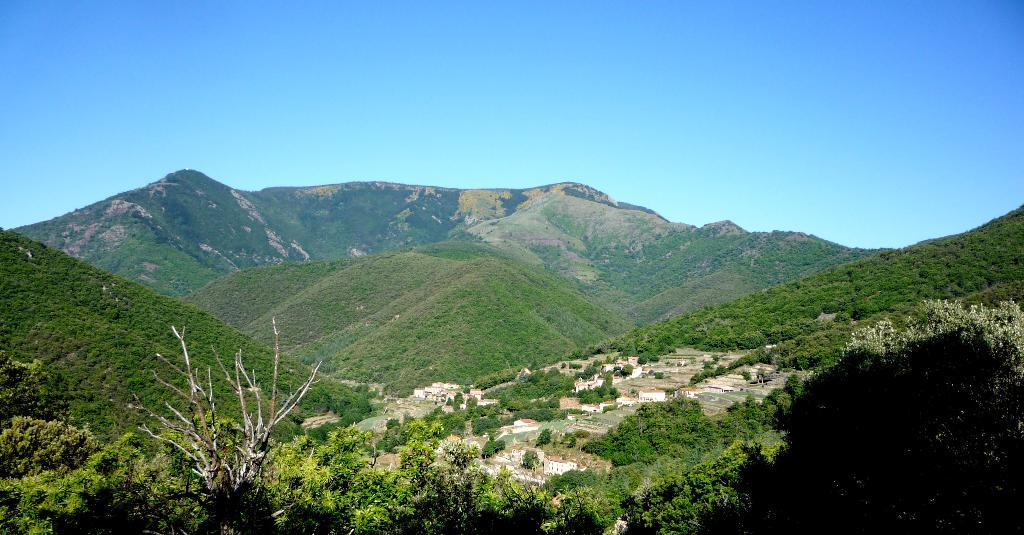What type of natural formation can be seen in the image? There are mountains in the image. What type of vegetation is present in the image? There are trees with branches and leaves in the image. What type of man-made structures are visible in the image? There are houses in the image. What is visible in the background of the image? The sky is visible in the image. What is the price of the geese in the image? There are no geese present in the image, so it is not possible to determine their price. 